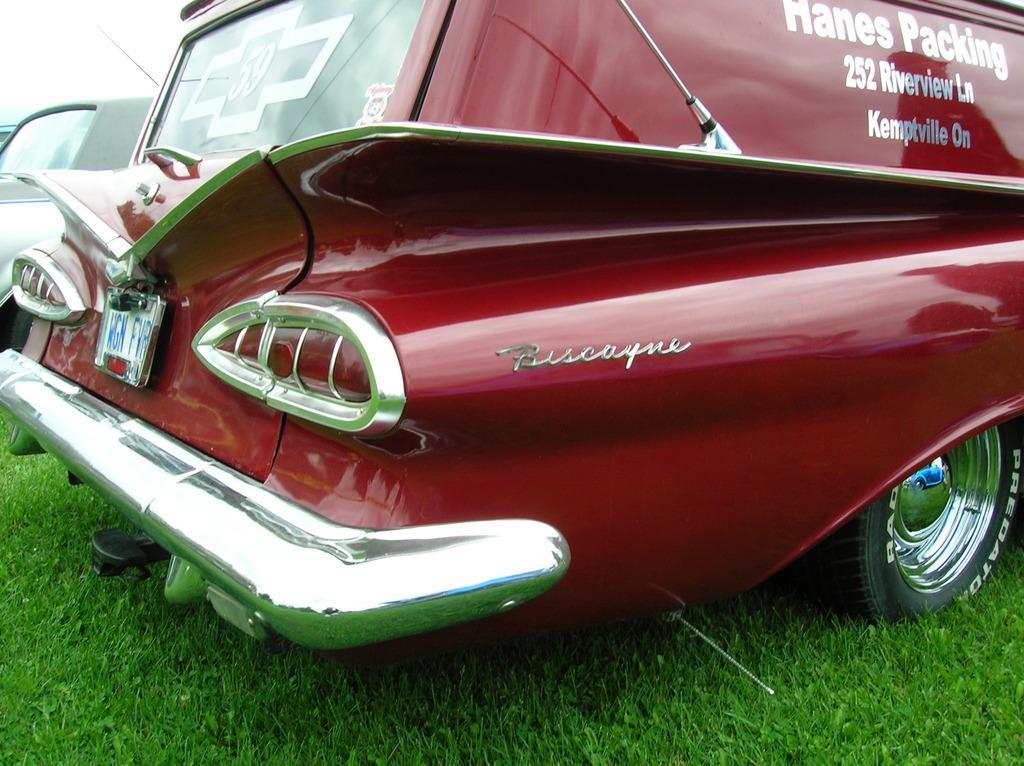In one or two sentences, can you explain what this image depicts? In this image we can see cars. At the bottom of the image there is grass. 